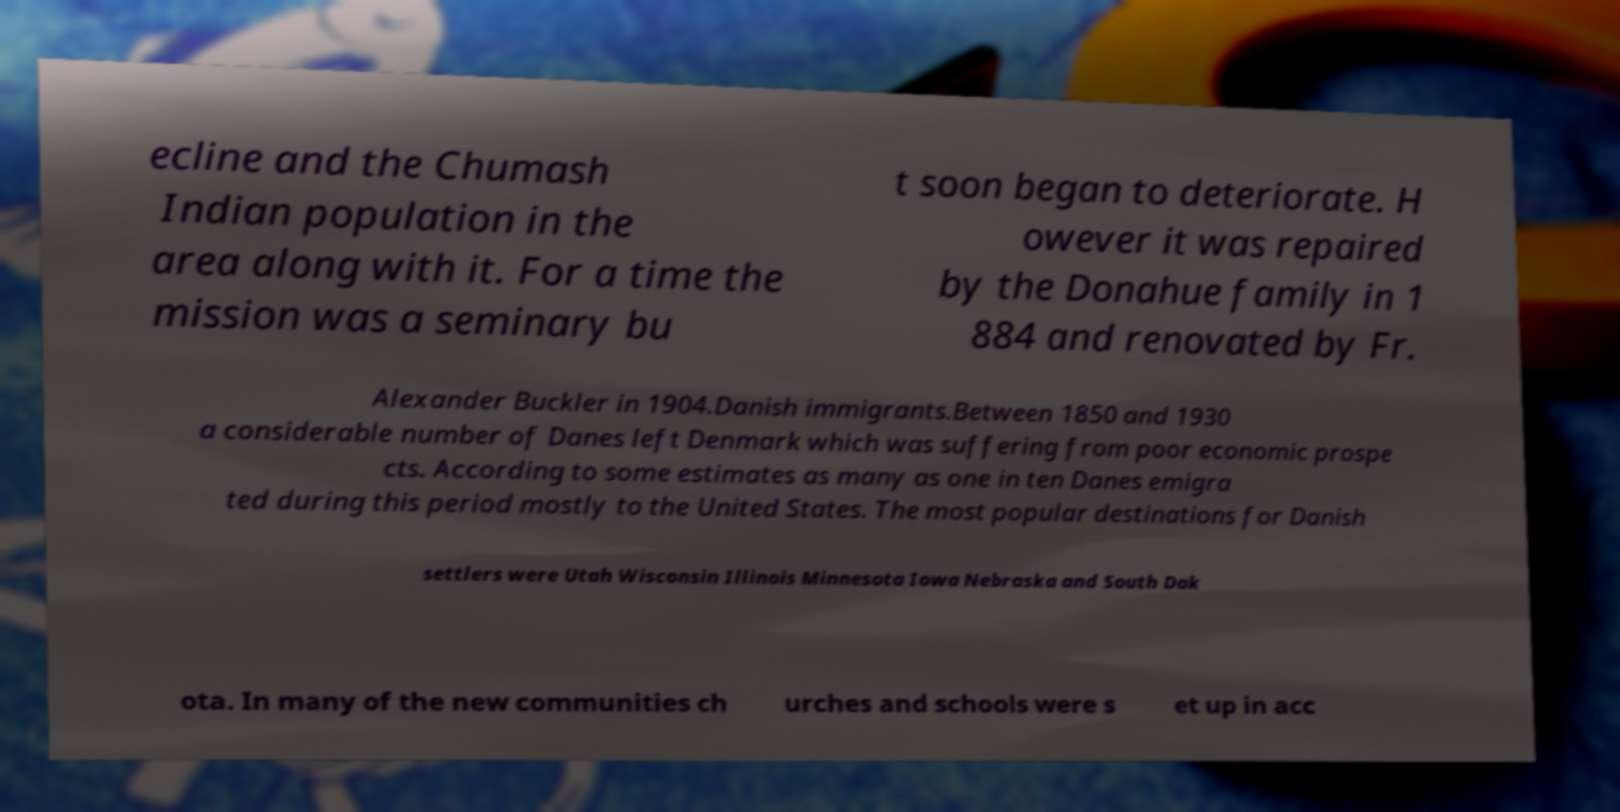Could you extract and type out the text from this image? ecline and the Chumash Indian population in the area along with it. For a time the mission was a seminary bu t soon began to deteriorate. H owever it was repaired by the Donahue family in 1 884 and renovated by Fr. Alexander Buckler in 1904.Danish immigrants.Between 1850 and 1930 a considerable number of Danes left Denmark which was suffering from poor economic prospe cts. According to some estimates as many as one in ten Danes emigra ted during this period mostly to the United States. The most popular destinations for Danish settlers were Utah Wisconsin Illinois Minnesota Iowa Nebraska and South Dak ota. In many of the new communities ch urches and schools were s et up in acc 